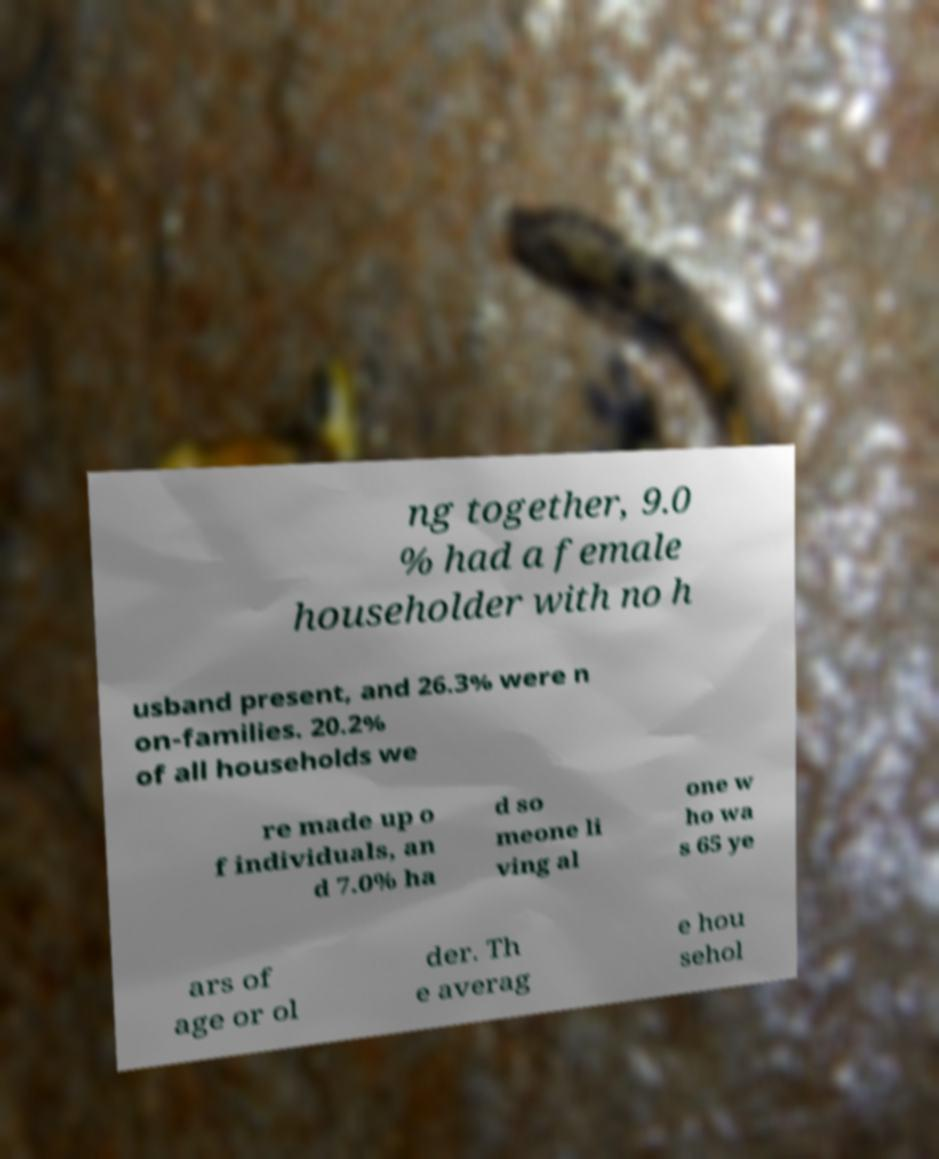Could you assist in decoding the text presented in this image and type it out clearly? ng together, 9.0 % had a female householder with no h usband present, and 26.3% were n on-families. 20.2% of all households we re made up o f individuals, an d 7.0% ha d so meone li ving al one w ho wa s 65 ye ars of age or ol der. Th e averag e hou sehol 